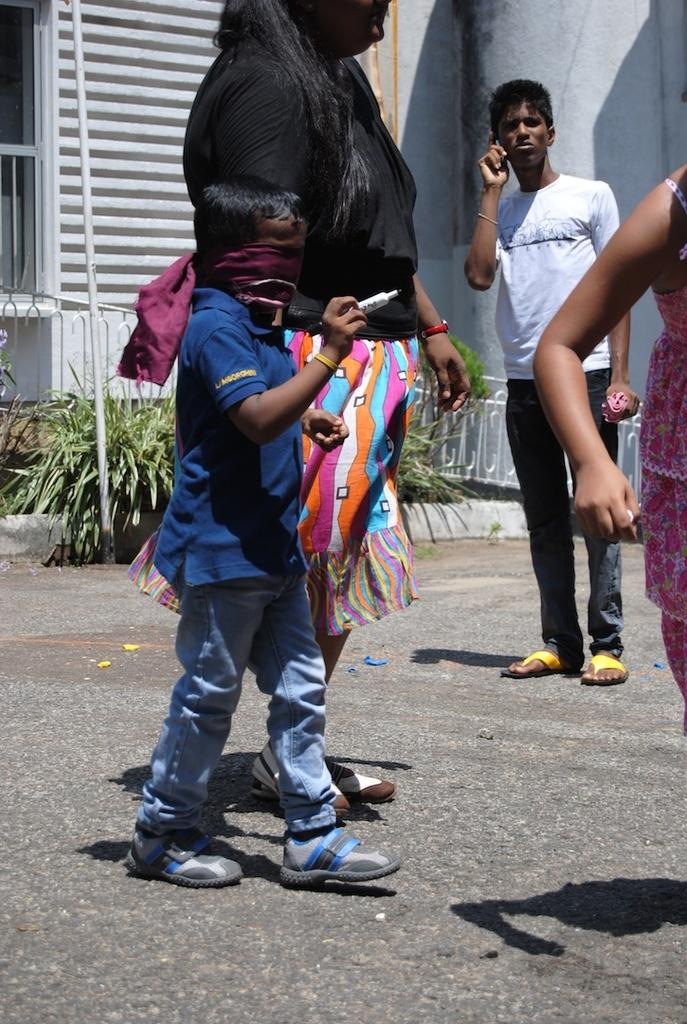What can be observed about the people in the image? There are people standing in the image. Can you describe the appearance of one of the individuals? There is a kid wearing a face mask in the image. What type of structures are present in the image? There are poles and metal railing in the image. What type of natural elements can be seen in the image? There are plants in the image. What type of person is flying the airplane in the image? There is no airplane present in the image, so it is not possible to answer that question. 